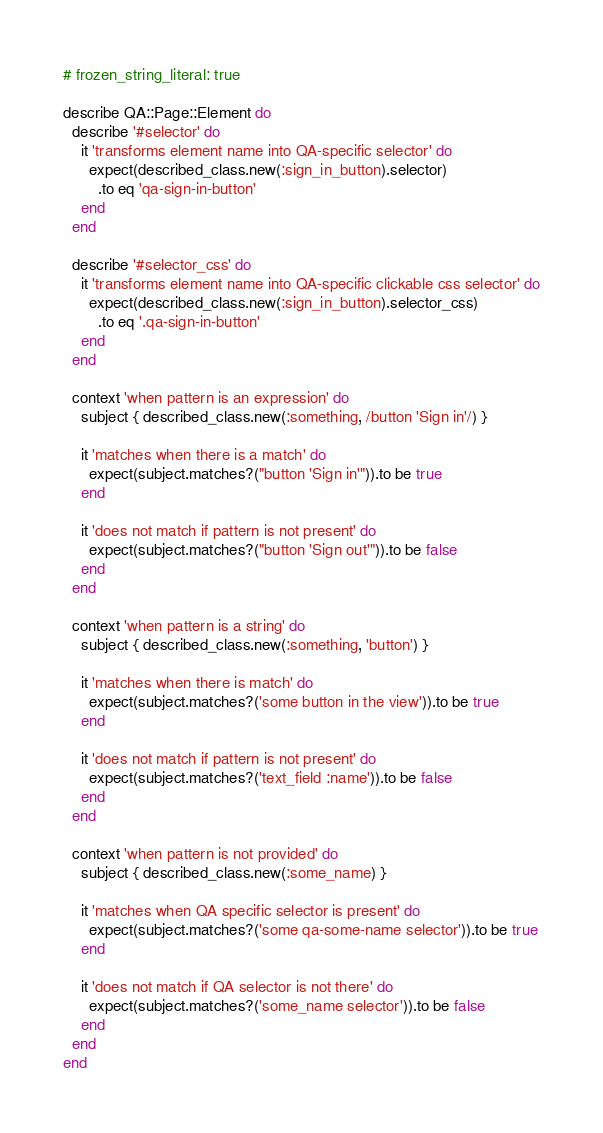Convert code to text. <code><loc_0><loc_0><loc_500><loc_500><_Ruby_># frozen_string_literal: true

describe QA::Page::Element do
  describe '#selector' do
    it 'transforms element name into QA-specific selector' do
      expect(described_class.new(:sign_in_button).selector)
        .to eq 'qa-sign-in-button'
    end
  end

  describe '#selector_css' do
    it 'transforms element name into QA-specific clickable css selector' do
      expect(described_class.new(:sign_in_button).selector_css)
        .to eq '.qa-sign-in-button'
    end
  end

  context 'when pattern is an expression' do
    subject { described_class.new(:something, /button 'Sign in'/) }

    it 'matches when there is a match' do
      expect(subject.matches?("button 'Sign in'")).to be true
    end

    it 'does not match if pattern is not present' do
      expect(subject.matches?("button 'Sign out'")).to be false
    end
  end

  context 'when pattern is a string' do
    subject { described_class.new(:something, 'button') }

    it 'matches when there is match' do
      expect(subject.matches?('some button in the view')).to be true
    end

    it 'does not match if pattern is not present' do
      expect(subject.matches?('text_field :name')).to be false
    end
  end

  context 'when pattern is not provided' do
    subject { described_class.new(:some_name) }

    it 'matches when QA specific selector is present' do
      expect(subject.matches?('some qa-some-name selector')).to be true
    end

    it 'does not match if QA selector is not there' do
      expect(subject.matches?('some_name selector')).to be false
    end
  end
end
</code> 